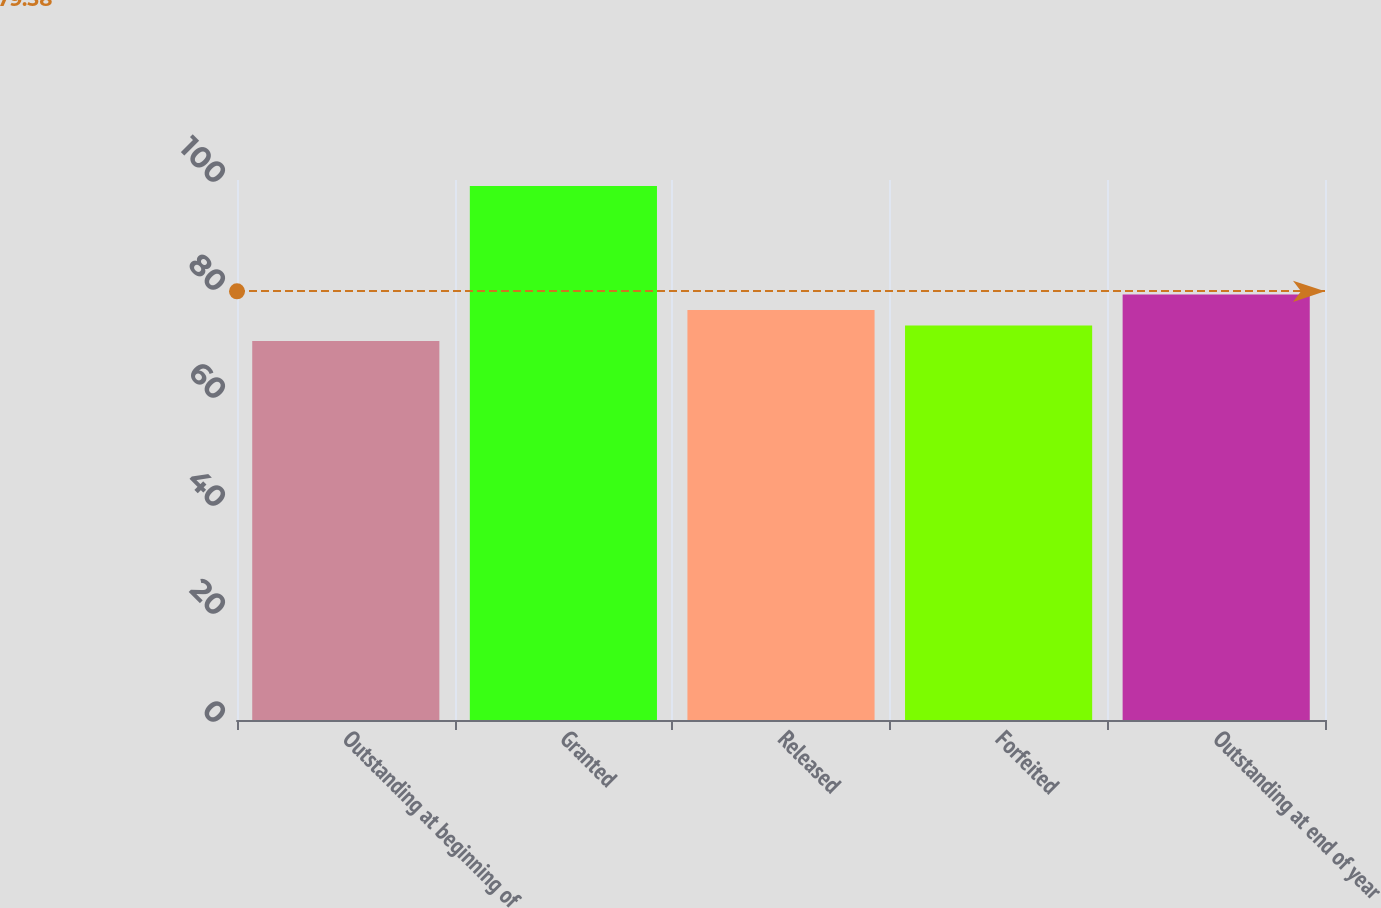Convert chart. <chart><loc_0><loc_0><loc_500><loc_500><bar_chart><fcel>Outstanding at beginning of<fcel>Granted<fcel>Released<fcel>Forfeited<fcel>Outstanding at end of year<nl><fcel>70.19<fcel>98.9<fcel>75.93<fcel>73.06<fcel>78.8<nl></chart> 